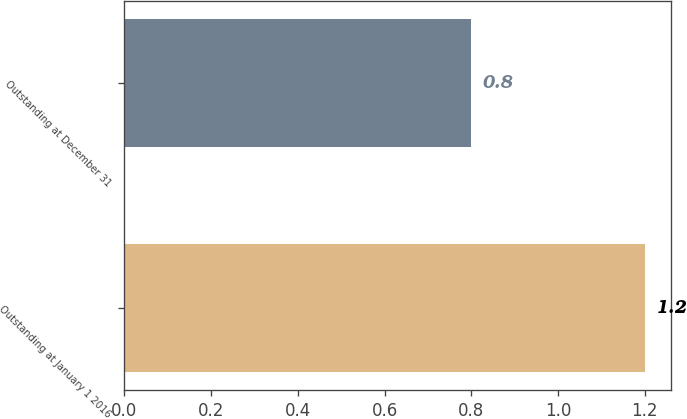<chart> <loc_0><loc_0><loc_500><loc_500><bar_chart><fcel>Outstanding at January 1 2016<fcel>Outstanding at December 31<nl><fcel>1.2<fcel>0.8<nl></chart> 